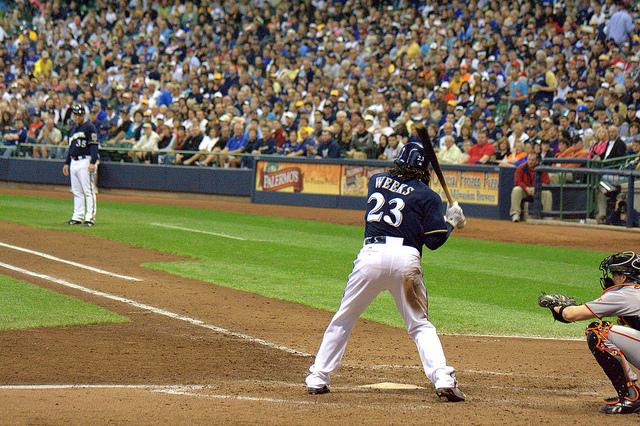What is the batters name?
Concise answer only. Weeks. What is the number of the batter?
Write a very short answer. 23. Is there a big crowd watching?
Quick response, please. Yes. 